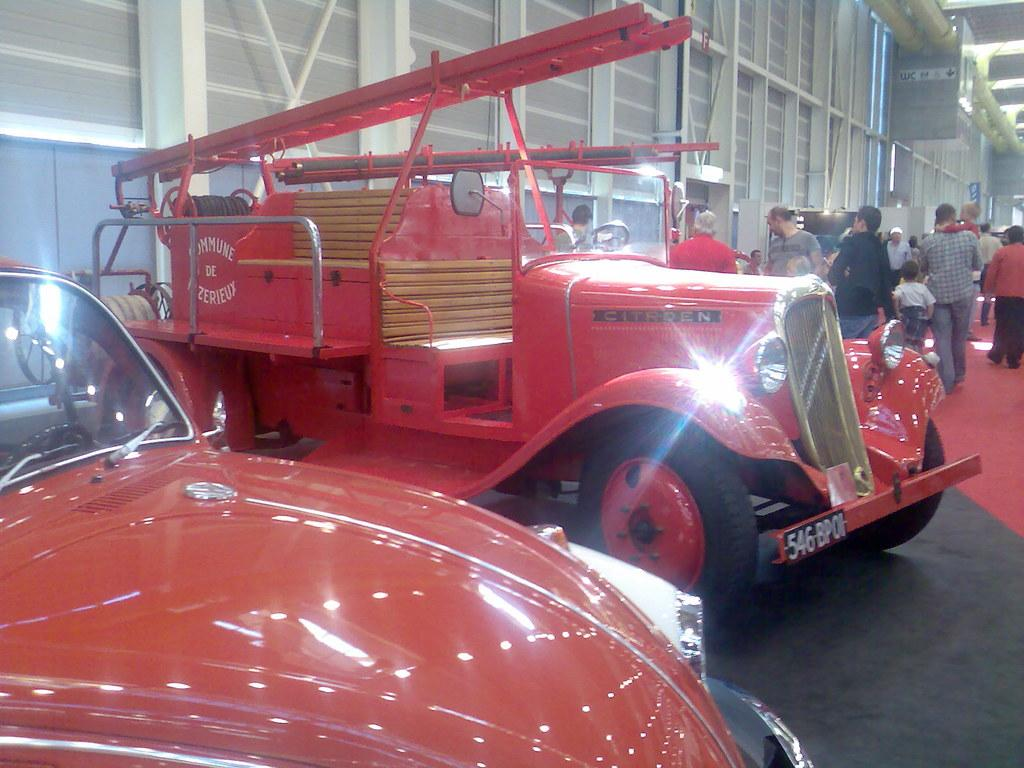What objects are on the floor in the image? There are vehicles on the floor in the image. What can be seen in the background of the image? There are people standing in the background of the image. What is visible in the image that might serve as a barrier or divider? There is a wall visible in the image. What might provide illumination in the image? Lights are present in the image. What other items can be seen in the image besides the vehicles, people, wall, and lights? There are other objects in the image. What type of stretch can be seen on the quilt in the image? There is no quilt or stretch present in the image. What is the size of the hall in the image? There is no hall present in the image. 